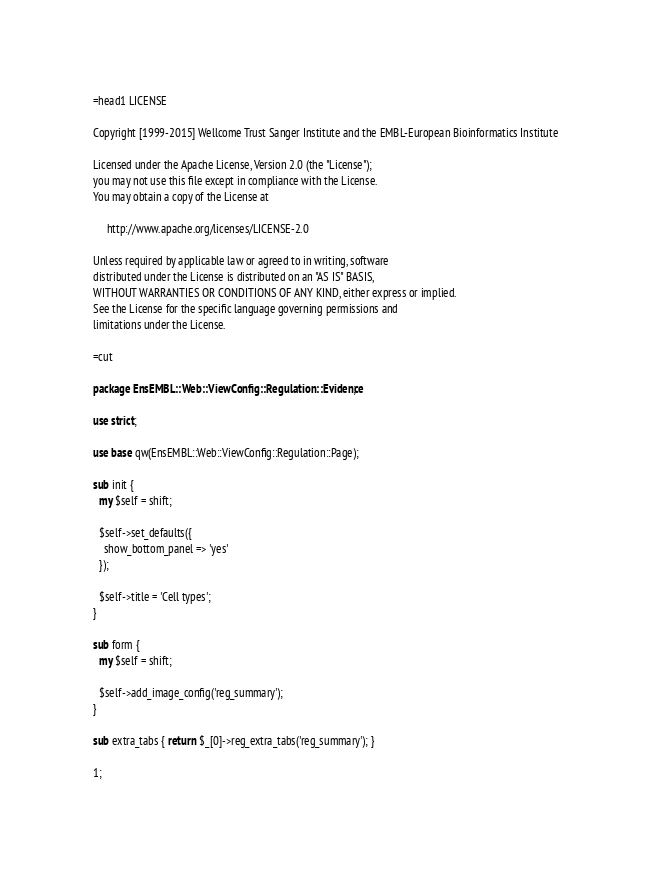<code> <loc_0><loc_0><loc_500><loc_500><_Perl_>=head1 LICENSE

Copyright [1999-2015] Wellcome Trust Sanger Institute and the EMBL-European Bioinformatics Institute

Licensed under the Apache License, Version 2.0 (the "License");
you may not use this file except in compliance with the License.
You may obtain a copy of the License at

     http://www.apache.org/licenses/LICENSE-2.0

Unless required by applicable law or agreed to in writing, software
distributed under the License is distributed on an "AS IS" BASIS,
WITHOUT WARRANTIES OR CONDITIONS OF ANY KIND, either express or implied.
See the License for the specific language governing permissions and
limitations under the License.

=cut

package EnsEMBL::Web::ViewConfig::Regulation::Evidence;

use strict;

use base qw(EnsEMBL::Web::ViewConfig::Regulation::Page);

sub init {
  my $self = shift;

  $self->set_defaults({
    show_bottom_panel => 'yes'
  });
  
  $self->title = 'Cell types';
}

sub form {
  my $self = shift;

  $self->add_image_config('reg_summary');
}

sub extra_tabs { return $_[0]->reg_extra_tabs('reg_summary'); }

1;
</code> 